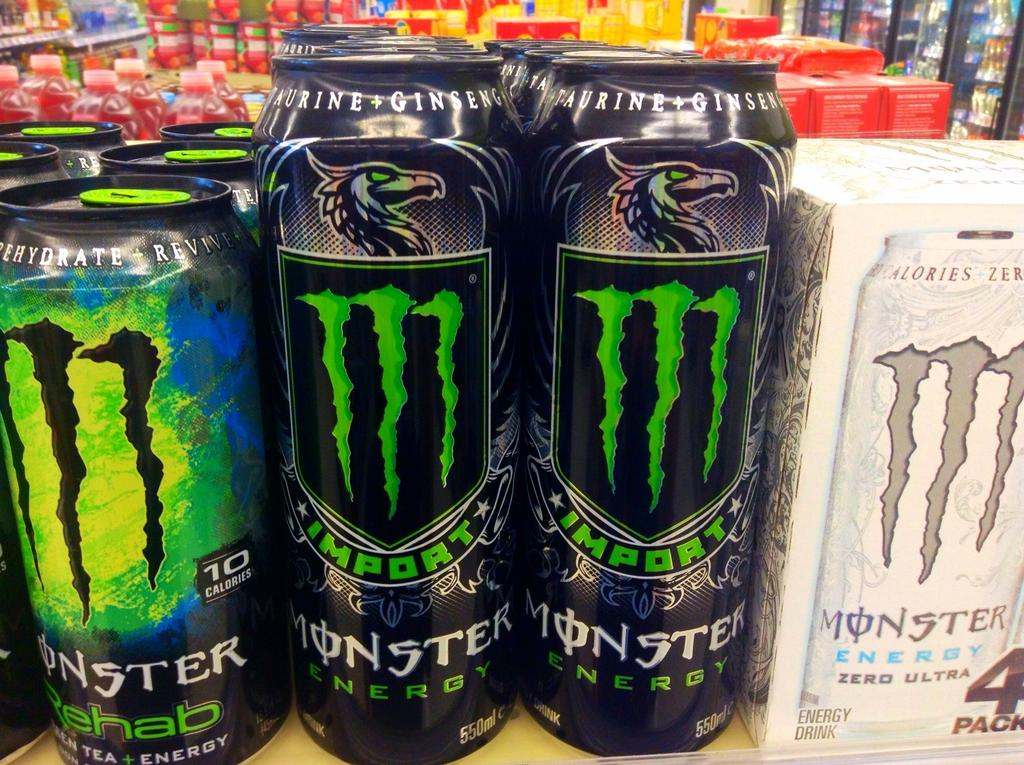Provide a one-sentence caption for the provided image. Cans of Monster Energy Drink and a 4 pack box of such on a shelf. 